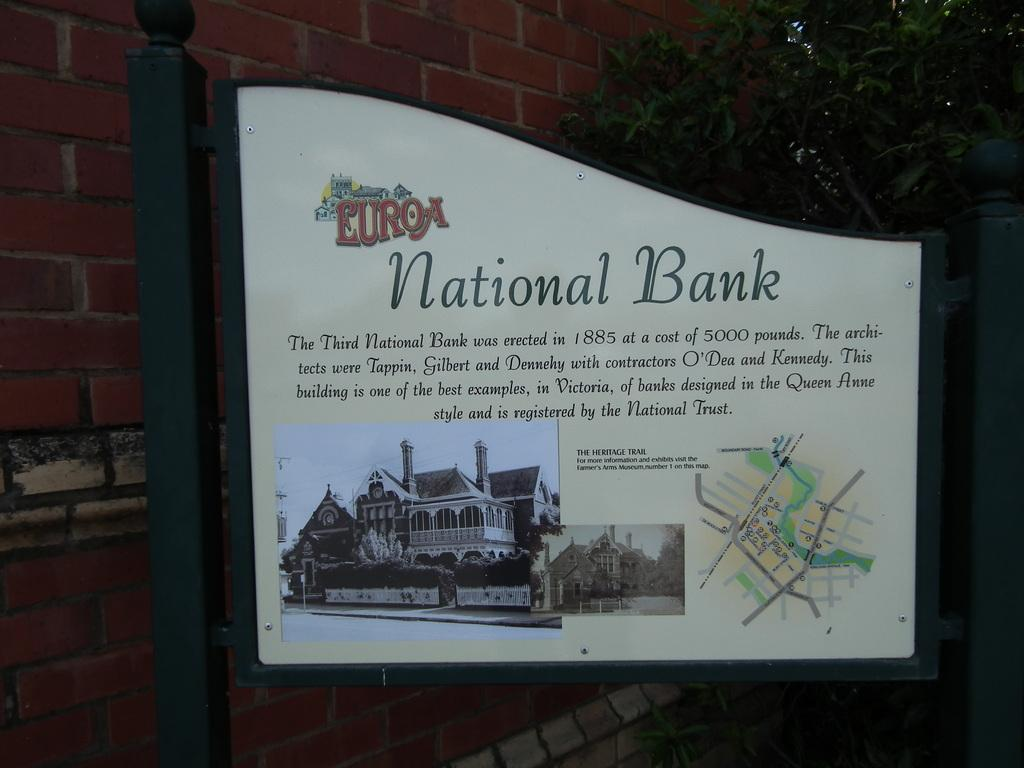<image>
Create a compact narrative representing the image presented. "EuroA national bank" sign gives information on the bank. 